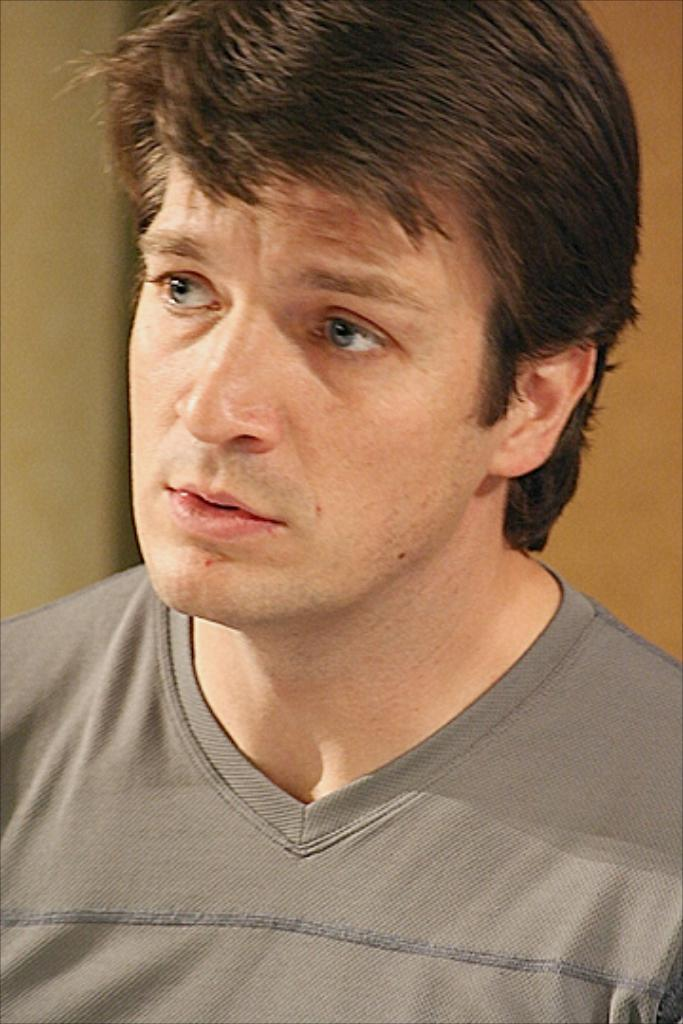What is the main subject in the center of the image? There is a man in the center of the image. What can be seen in the background of the image? There is a wall in the background of the image. What type of fork can be seen flying in the image? There is no fork present in the image, and therefore no such activity can be observed. 